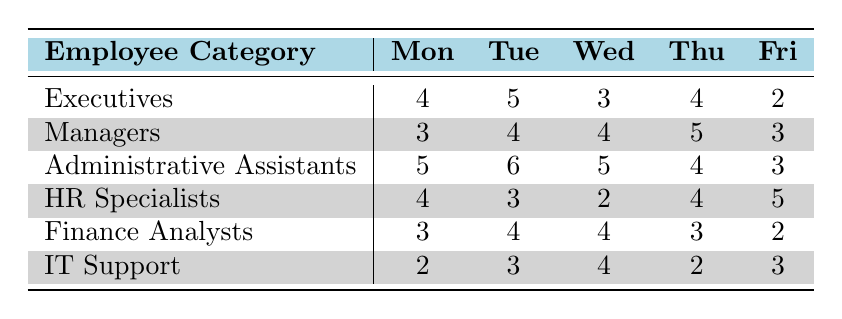What is the total time Executives spend on administrative tasks over the week? Add the values for each day: Monday (4) + Tuesday (5) + Wednesday (3) + Thursday (4) + Friday (2) = 18
Answer: 18 Which Employee Category spends the most time on Tuesday? Looking at the Tuesday column, Administrative Assistants (6) have the highest value compared to other categories.
Answer: Administrative Assistants What is the average time spent on administrative tasks by HR Specialists for the week? The total for HR Specialists is Monday (4) + Tuesday (3) + Wednesday (2) + Thursday (4) + Friday (5) = 18. To find the average, divide by the number of days: 18/5 = 3.6
Answer: 3.6 Is it true that Managers spend more time on Thursday than on Wednesday? Compare the values: Managers spend 5 hours on Thursday and 4 hours on Wednesday. Since 5 is greater than 4, the statement is true.
Answer: Yes What is the total time spent by IT Support on Monday and Tuesday combined? Add the values for IT Support: Monday (2) + Tuesday (3) = 5.
Answer: 5 Which day has the least amount of overall time spent across all categories? Calculate the total for each day: Monday = 4 + 3 + 5 + 4 + 3 + 2 = 21, Tuesday = 5 + 4 + 6 + 3 + 4 + 3 = 25, Wednesday = 3 + 4 + 5 + 2 + 4 + 4 = 22, Thursday = 4 + 5 + 4 + 4 + 3 + 2 = 22, Friday = 2 + 3 + 3 + 5 + 2 + 3 = 18. Friday has the lowest total of 18.
Answer: Friday What is the difference in time spent between Executives and Administrative Assistants on Wednesday? Executives spend 3 hours and Administrative Assistants spend 5 hours on Wednesday. The difference is 5 - 3 = 2.
Answer: 2 How many total hours did Finance Analysts spend on administrative tasks over the week? For Finance Analysts: Monday (3) + Tuesday (4) + Wednesday (4) + Thursday (3) + Friday (2) = 16.
Answer: 16 